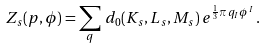<formula> <loc_0><loc_0><loc_500><loc_500>Z _ { s } ( p , \phi ) = \sum _ { q } \, d _ { 0 } ( K _ { s } , L _ { s } , M _ { s } ) \, e ^ { \frac { 1 } { 3 } \pi \, q _ { I } \phi ^ { I } } \, .</formula> 